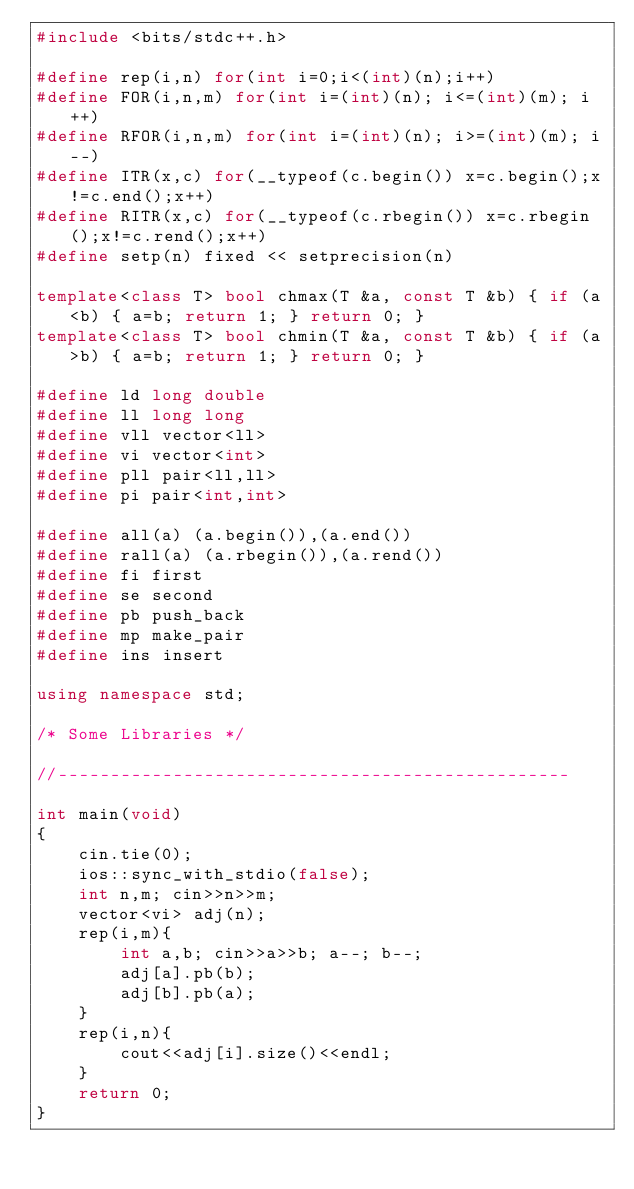<code> <loc_0><loc_0><loc_500><loc_500><_C++_>#include <bits/stdc++.h>

#define rep(i,n) for(int i=0;i<(int)(n);i++)
#define FOR(i,n,m) for(int i=(int)(n); i<=(int)(m); i++)
#define RFOR(i,n,m) for(int i=(int)(n); i>=(int)(m); i--)
#define ITR(x,c) for(__typeof(c.begin()) x=c.begin();x!=c.end();x++)
#define RITR(x,c) for(__typeof(c.rbegin()) x=c.rbegin();x!=c.rend();x++)
#define setp(n) fixed << setprecision(n)

template<class T> bool chmax(T &a, const T &b) { if (a<b) { a=b; return 1; } return 0; }
template<class T> bool chmin(T &a, const T &b) { if (a>b) { a=b; return 1; } return 0; }

#define ld long double
#define ll long long
#define vll vector<ll>
#define vi vector<int>
#define pll pair<ll,ll>
#define pi pair<int,int>

#define all(a) (a.begin()),(a.end())
#define rall(a) (a.rbegin()),(a.rend())
#define fi first
#define se second
#define pb push_back
#define mp make_pair
#define ins insert

using namespace std;

/* Some Libraries */

//-------------------------------------------------

int main(void)
{
    cin.tie(0);
    ios::sync_with_stdio(false);
    int n,m; cin>>n>>m;
    vector<vi> adj(n);
    rep(i,m){
        int a,b; cin>>a>>b; a--; b--;
        adj[a].pb(b);
        adj[b].pb(a);
    }
    rep(i,n){
        cout<<adj[i].size()<<endl;
    }
    return 0;
}
</code> 